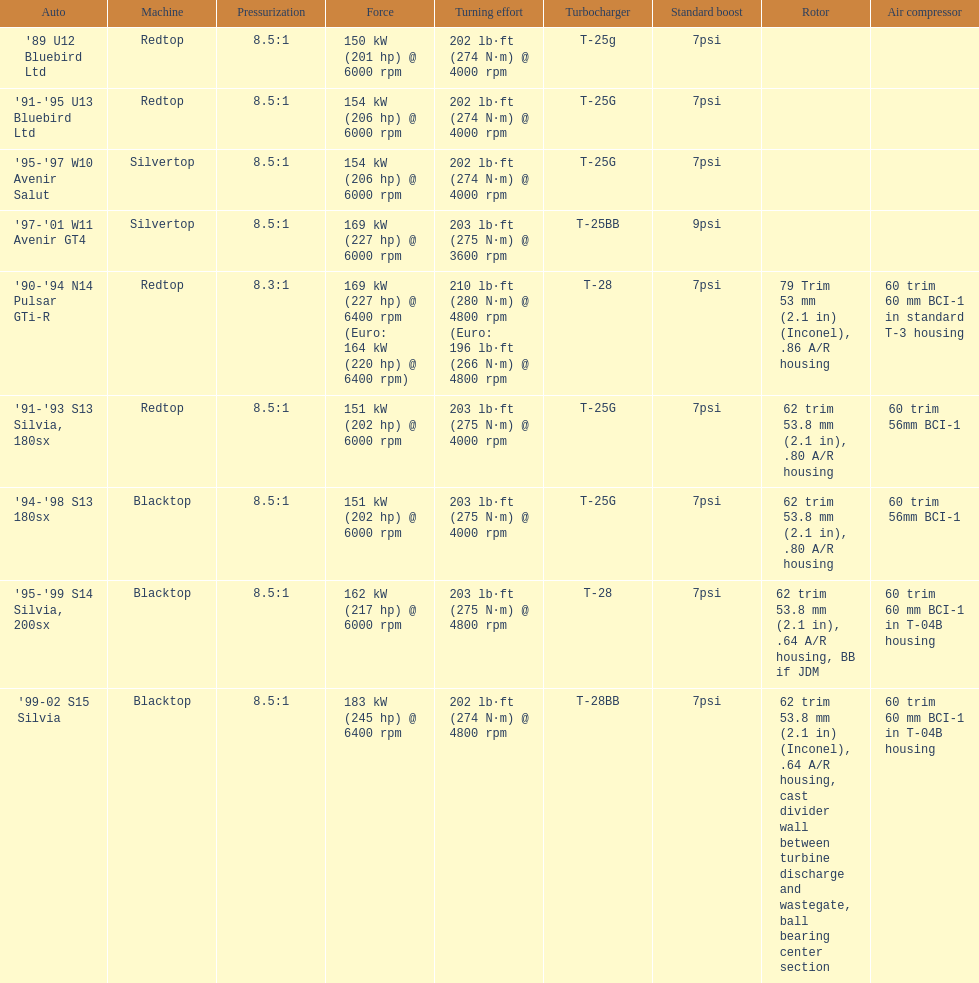Which car has a stock boost of over 7psi? '97-'01 W11 Avenir GT4. 